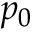<formula> <loc_0><loc_0><loc_500><loc_500>p _ { 0 }</formula> 